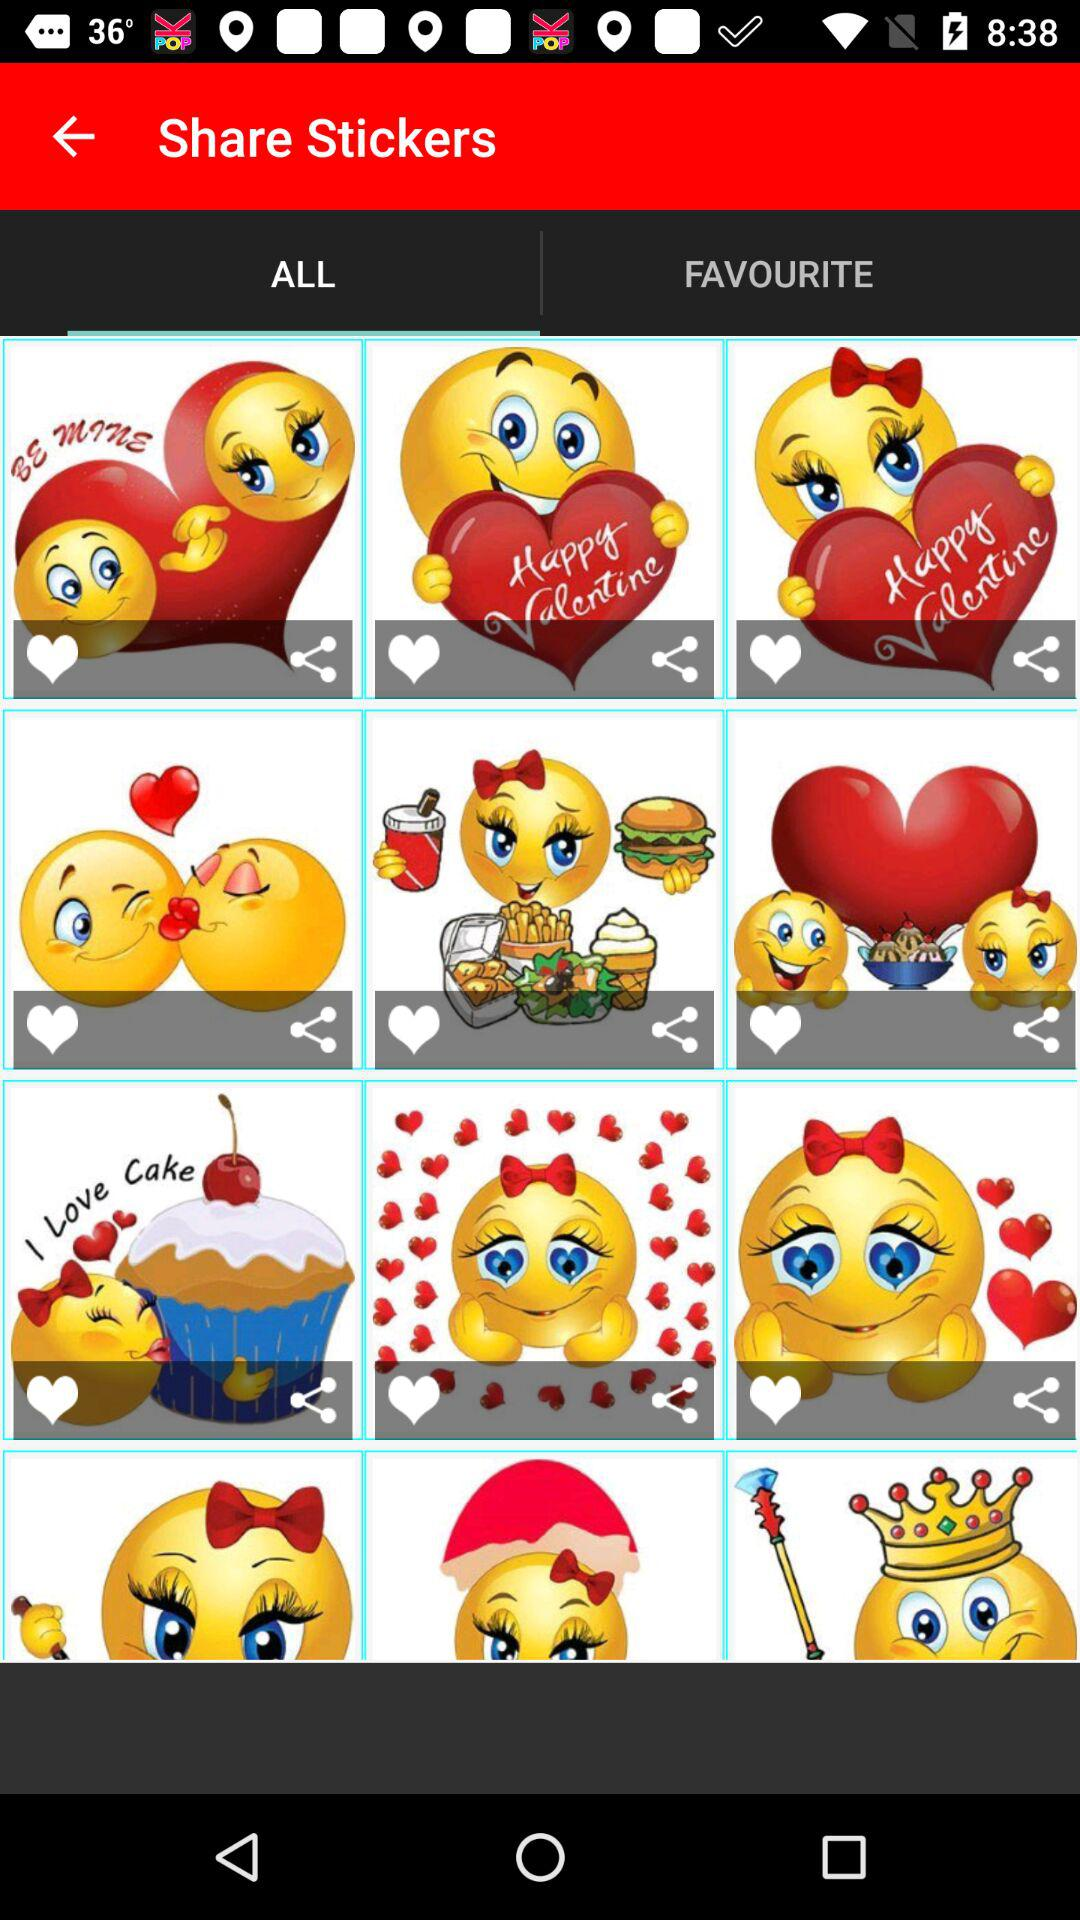What is the selected option? The selected option is "ALL". 